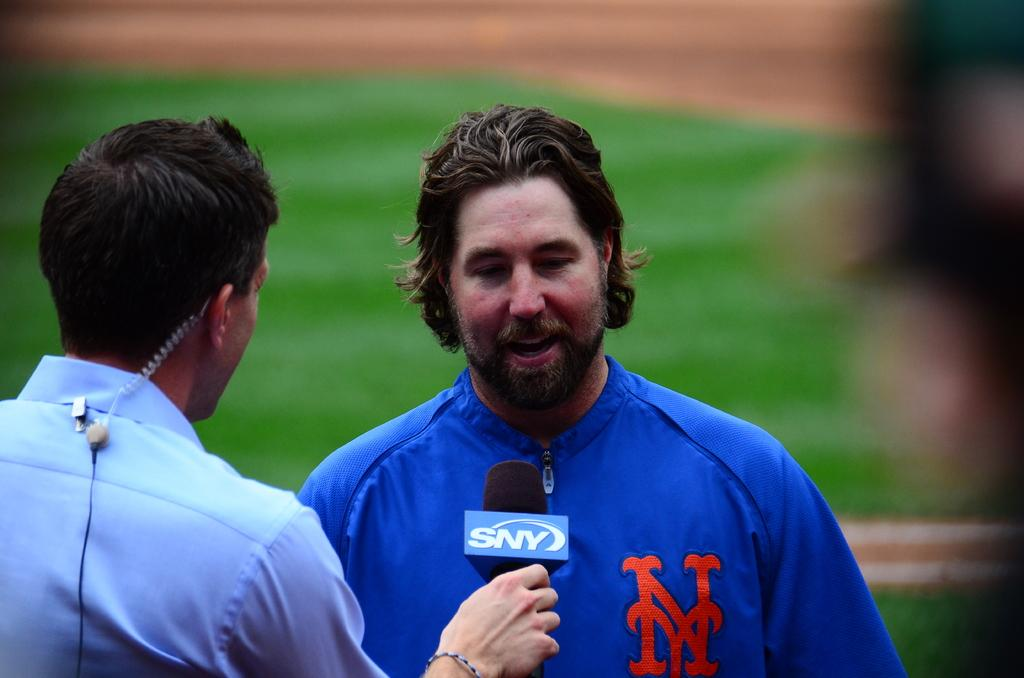<image>
Write a terse but informative summary of the picture. A man is holding a microphone with the letters SNY on it. 